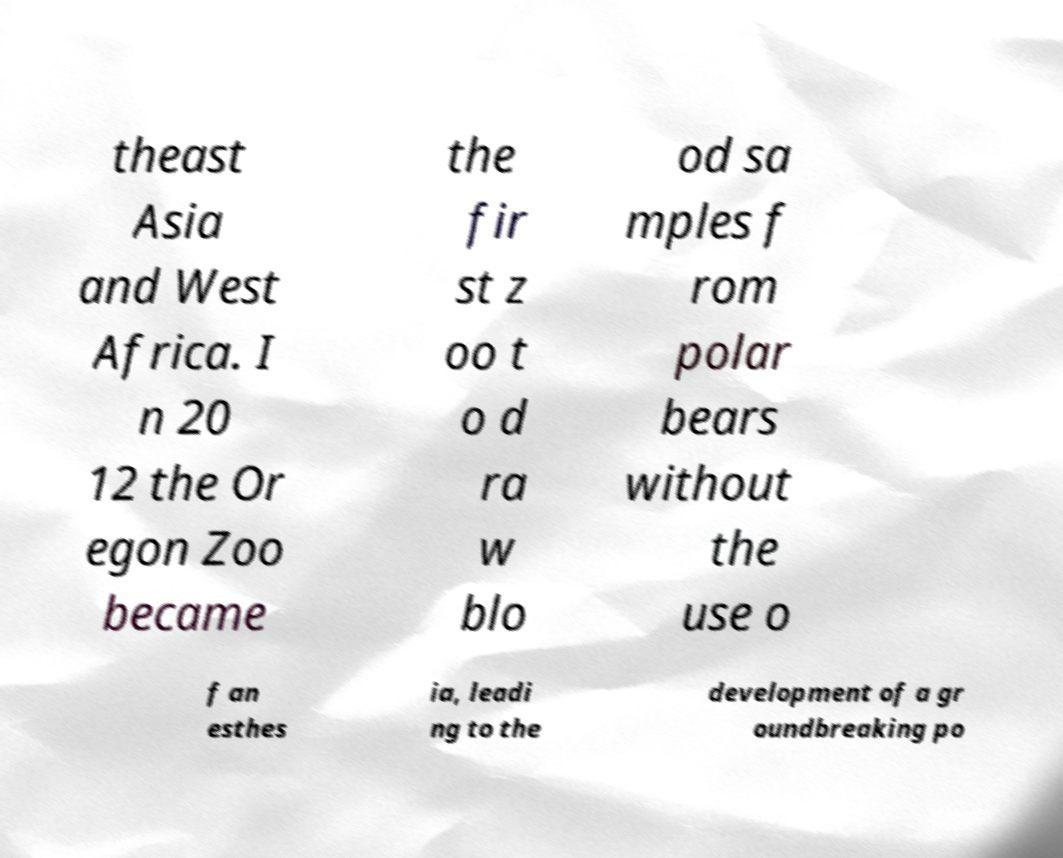Please read and relay the text visible in this image. What does it say? theast Asia and West Africa. I n 20 12 the Or egon Zoo became the fir st z oo t o d ra w blo od sa mples f rom polar bears without the use o f an esthes ia, leadi ng to the development of a gr oundbreaking po 